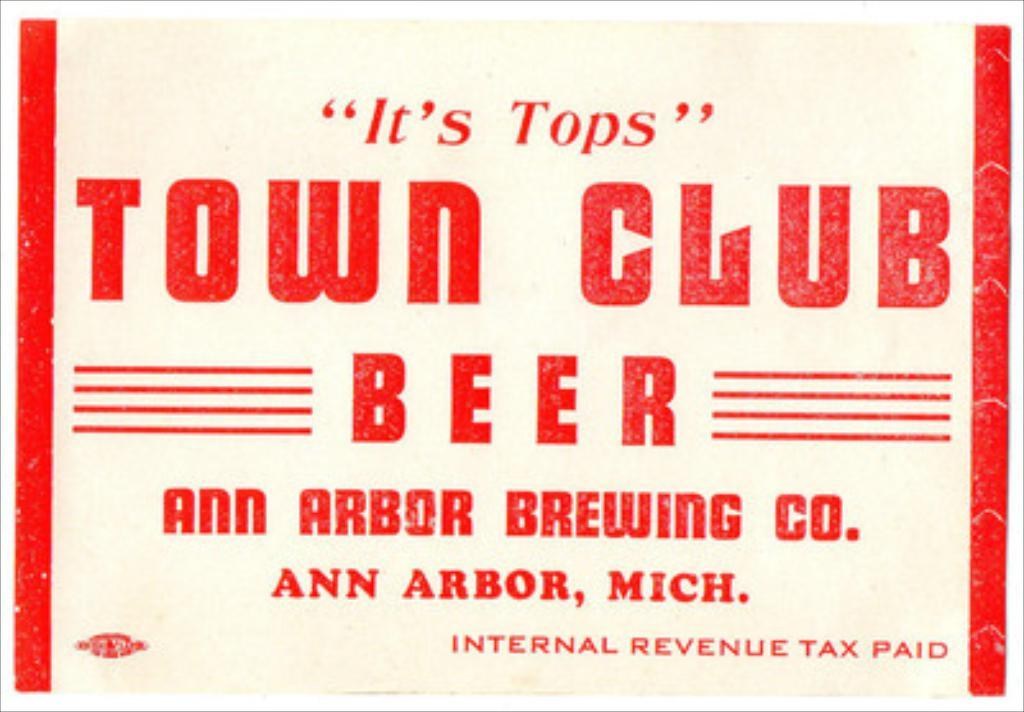<image>
Render a clear and concise summary of the photo. A old ad for Town Club beer, it is white with red lettering. 